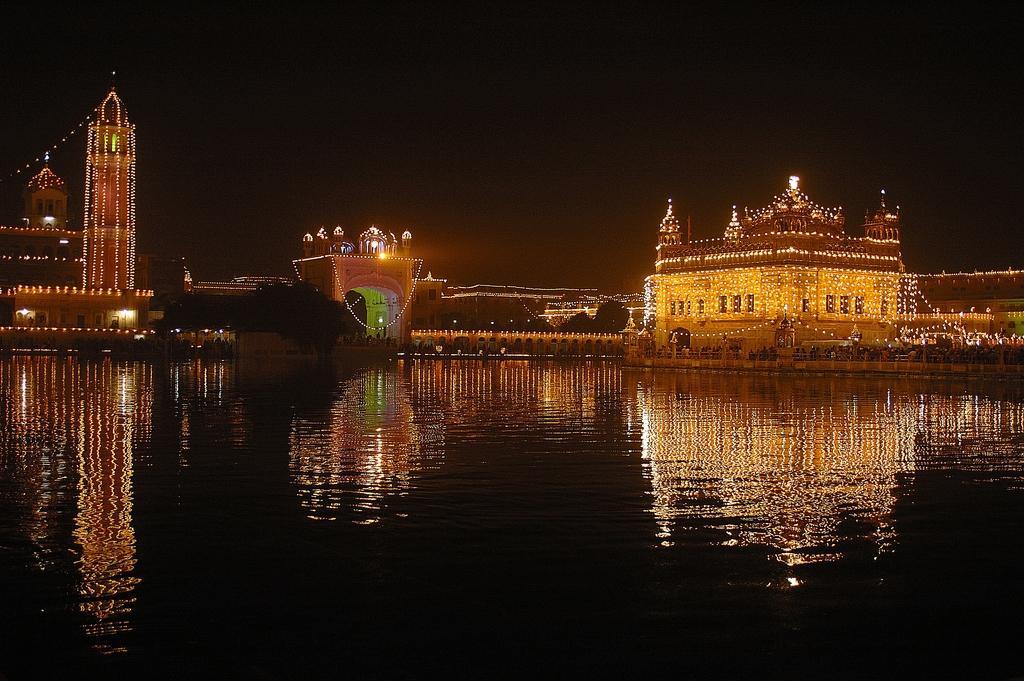Please provide a concise description of this image. In this image I can see water, few buildings and lights as decoration on these buildings. I can also see this image is little bit in dark. 